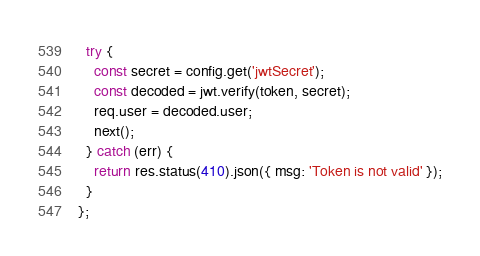Convert code to text. <code><loc_0><loc_0><loc_500><loc_500><_JavaScript_>  try {
    const secret = config.get('jwtSecret');
    const decoded = jwt.verify(token, secret);
    req.user = decoded.user;
    next();
  } catch (err) {
    return res.status(410).json({ msg: 'Token is not valid' });
  }
};
</code> 